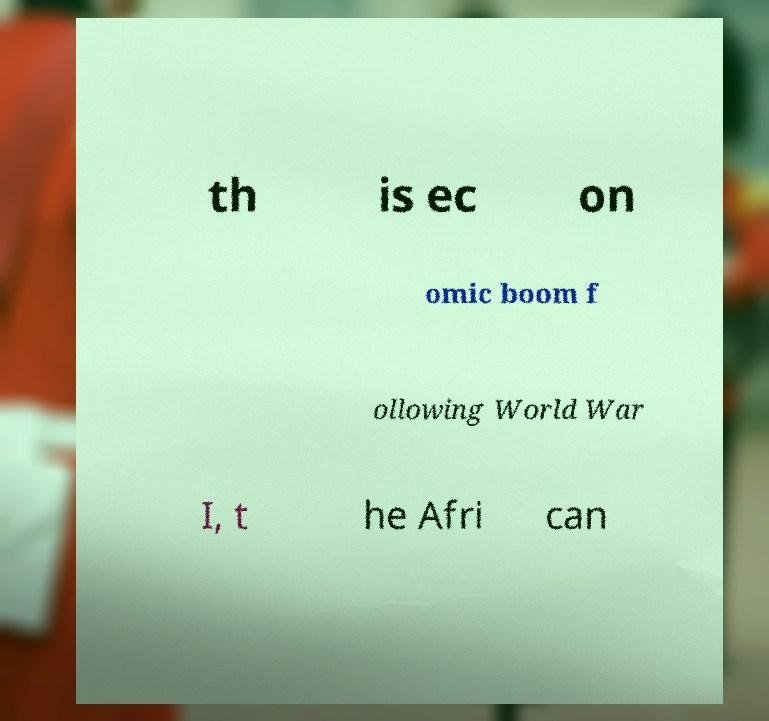Please read and relay the text visible in this image. What does it say? th is ec on omic boom f ollowing World War I, t he Afri can 